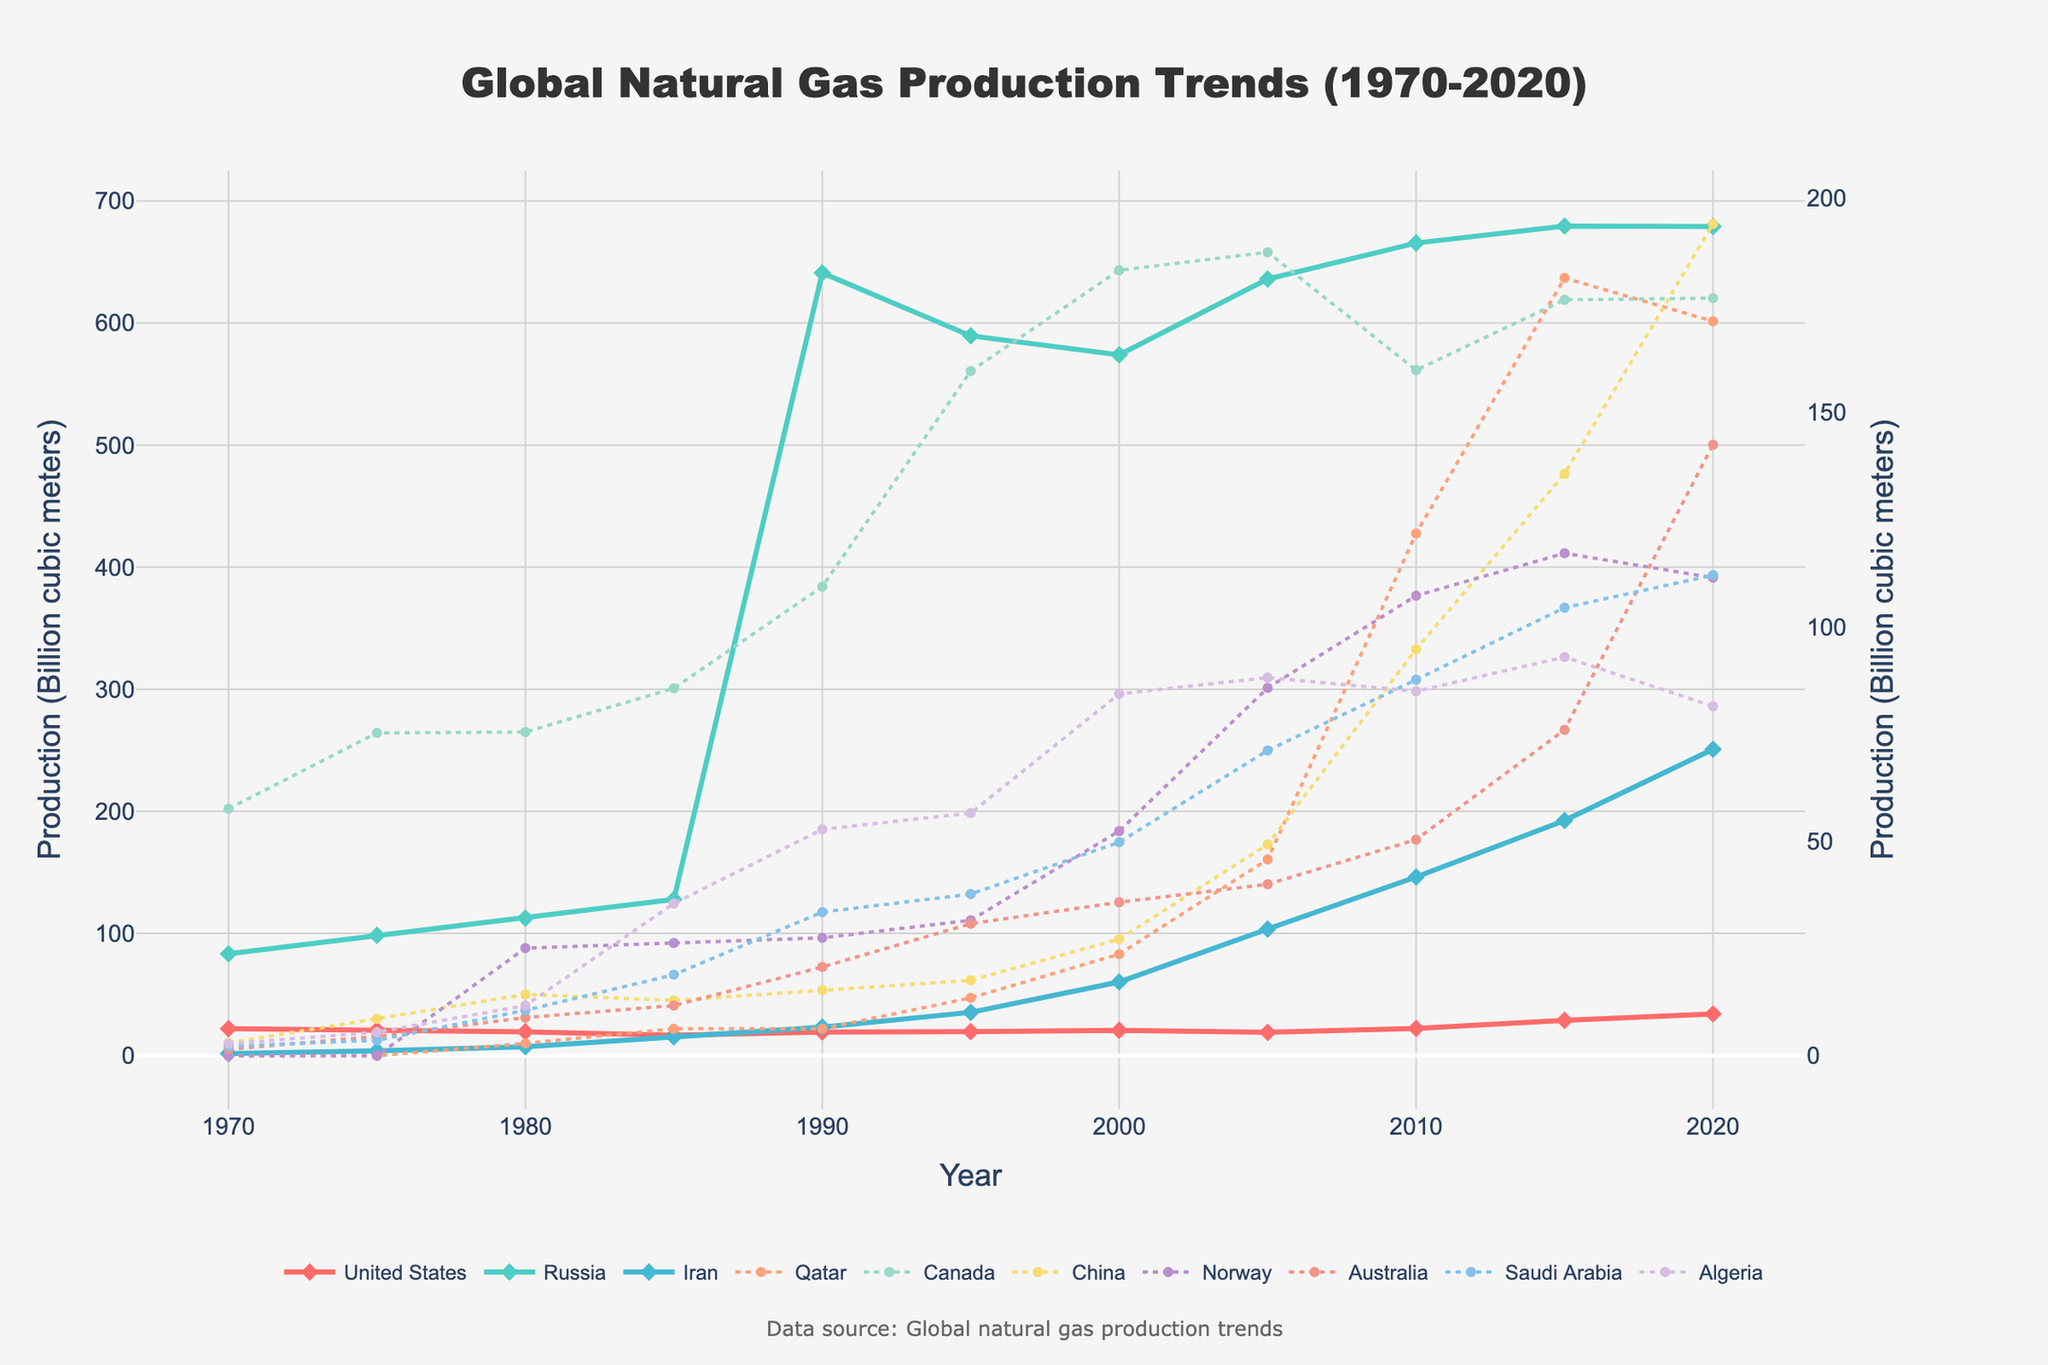Which country had the highest natural gas production in 2020? To find this, refer to the endpoint of the lines on the chart in 2020. The country with the highest value of production is the one whose line reaches the highest point.
Answer: Russia How much did the natural gas production increase in China from 1970 to 2020? Look at the production values for China at the starting year (1970) and the endpoint (2020) on the chart, then subtract the 1970 value from the 2020 value. Specifically, it increased from 3.0 billion cubic meters in 1970 to 194.0 billion cubic meters in 2020, so the difference is 194.0 - 3.0.
Answer: 191.0 billion cubic meters Which countries show a steady increase in natural gas production over the 50 years? By examining the slope of the lines for each country over the full time span, look for lines that consistently rise without significant drops. Countries such as Iran, China, and Qatar show a steady increase over the period.
Answer: Iran, China, Qatar What is the approximate total natural gas production of the United States, Russia, and Iran combined in the year 2015? Refer to the production values for each of these countries in 2015 and sum them up: 28.8 (United States) + 679.4 (Russia) + 192.5 (Iran).
Answer: 900.7 billion cubic meters By how much did Canada's production change from 1980 to 2000? Compare the values from 1980 and 2000 for Canada (75.5 and 183.2 billion cubic meters, respectively), and find the difference, which is 183.2 - 75.5.
Answer: 107.7 billion cubic meters Did any country surpass the United States in natural gas production by 2000? If so, which one(s)? Examine the values for the United States and compare them with other countries in 2000. Look for any country that has higher production values. Russia has 573.9, which is higher than the 20.6 of the United States.
Answer: Russia Which country shows the most dramatic increase in natural gas production between 1970 and 1990? Examine the difference in production values from 1970 to 1990 for all countries. Russia shows the most dramatic increase, growing from 83.3 to 641.0 billion cubic meters.
Answer: Russia What color represents Iran's production trend in the chart? Identify the color associated with Iran's production line, which is visibly distinct due to its color and plotting style.
Answer: Light Blue How did Norway’s natural gas production in 2020 compare to its production in 1980? Refer to the values in 1980 and 2020 for Norway (25.1 and 111.5 billion cubic meters respectively) and see the difference. Norway's production increased by 111.5 - 25.1.
Answer: Increased by 86.4 billion cubic meters What trend can be observed in Qatar's natural gas production over the 50-year period? Look at the trajectory of the line representing Qatar. It starts from 0 in 1970 and eventually sees significant growth especially towards the last two decades, indicating a marked increase.
Answer: Significant growth in the latter decades 